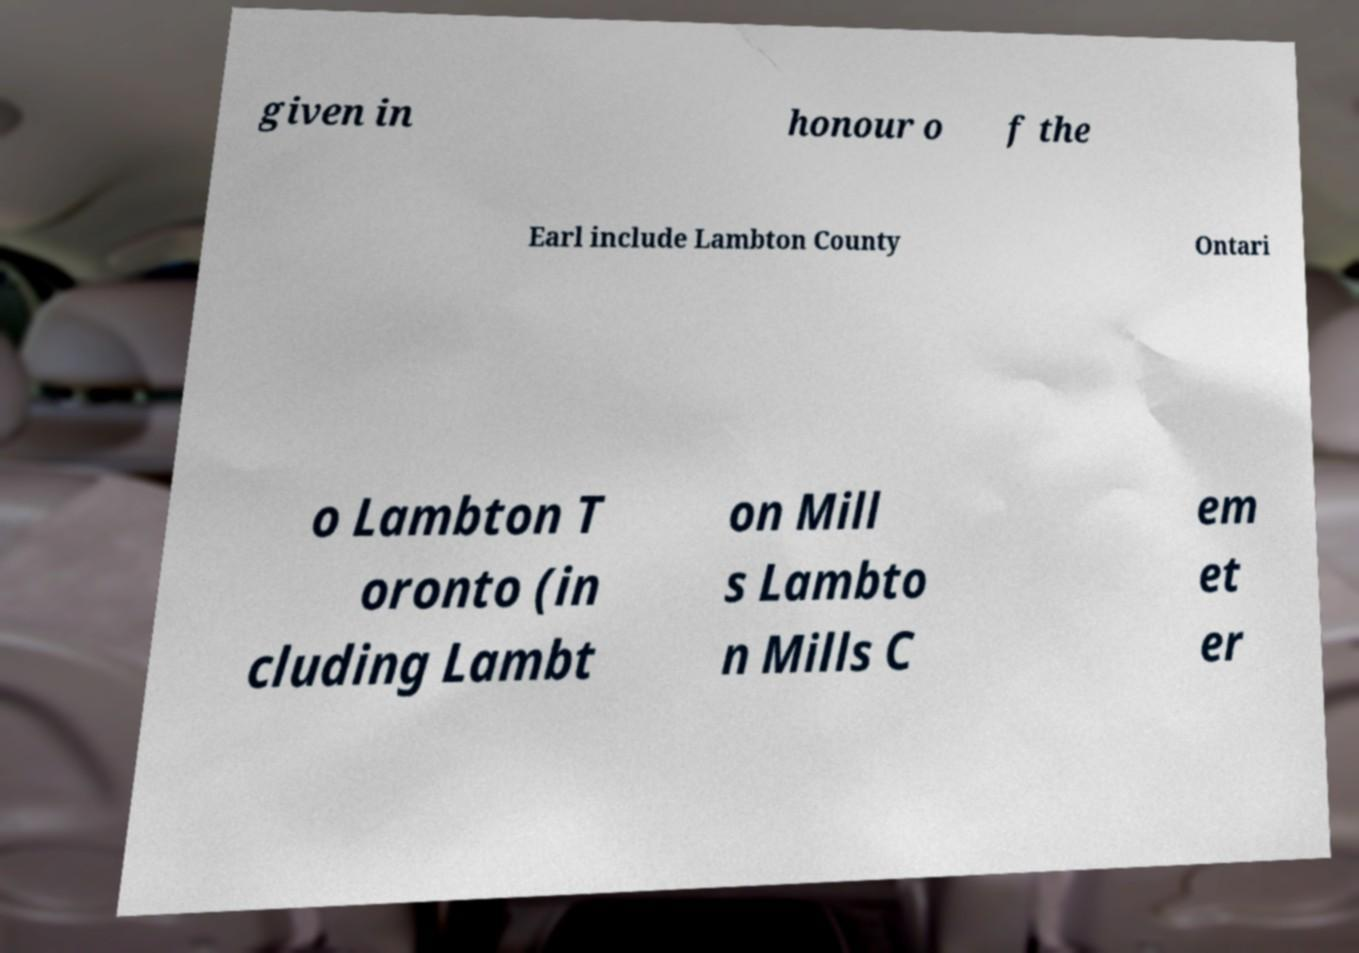Could you extract and type out the text from this image? given in honour o f the Earl include Lambton County Ontari o Lambton T oronto (in cluding Lambt on Mill s Lambto n Mills C em et er 